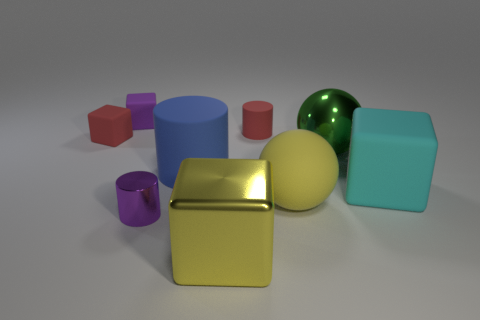Subtract all purple cylinders. Subtract all purple blocks. How many cylinders are left? 2 Add 1 big blue metal balls. How many objects exist? 10 Subtract all cubes. How many objects are left? 5 Subtract all tiny red objects. Subtract all purple things. How many objects are left? 5 Add 8 green things. How many green things are left? 9 Add 6 purple matte blocks. How many purple matte blocks exist? 7 Subtract 0 gray spheres. How many objects are left? 9 